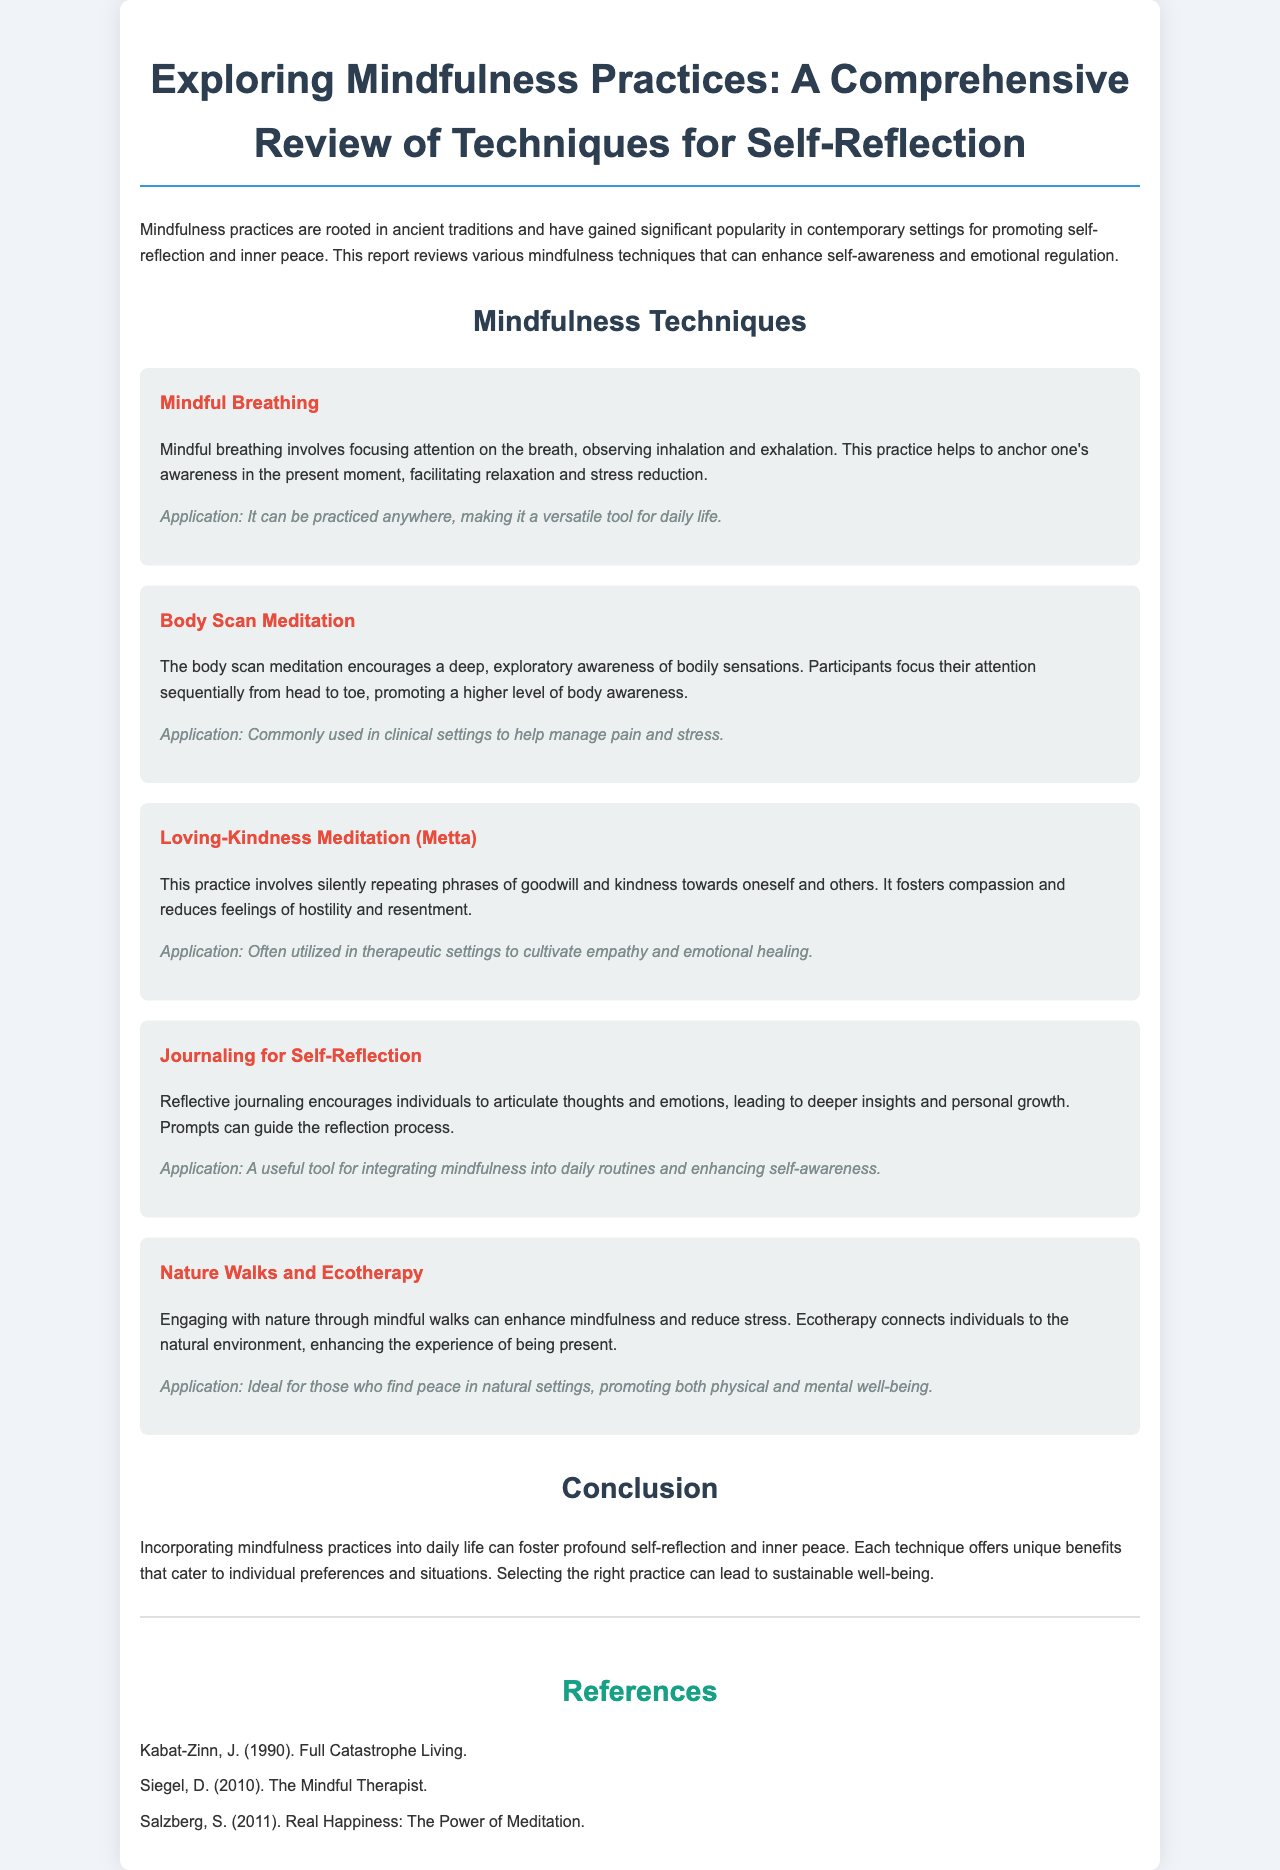What is the title of the report? The title of the report is found at the top of the document.
Answer: Exploring Mindfulness Practices: A Comprehensive Review of Techniques for Self-Reflection How many mindfulness techniques are reviewed in the document? The document lists techniques under the "Mindfulness Techniques" section.
Answer: Five What is the primary benefit of Mindful Breathing? The document states that Mindful Breathing helps to anchor one's awareness in the present moment, facilitating relaxation and stress reduction.
Answer: Relaxation and stress reduction Which technique is commonly used in clinical settings? The document mentions this technique under the "Body Scan Meditation" description.
Answer: Body Scan Meditation What meditation practice fosters compassion? The document mentions this practice in the section for Loving-Kindness Meditation.
Answer: Loving-Kindness Meditation What is a key application of Journaling for Self-Reflection? The document states it is a useful tool for integrating mindfulness into daily routines.
Answer: Enhancing self-awareness What type of environment does Ecotherapy connect individuals to? The document describes the environment related to "Nature Walks and Ecotherapy."
Answer: Natural environment What does the conclusion suggest about the mindfulness practices? The conclusion indicates that each technique offers unique benefits for self-reflection and inner peace.
Answer: Unique benefits for self-reflection and inner peace 